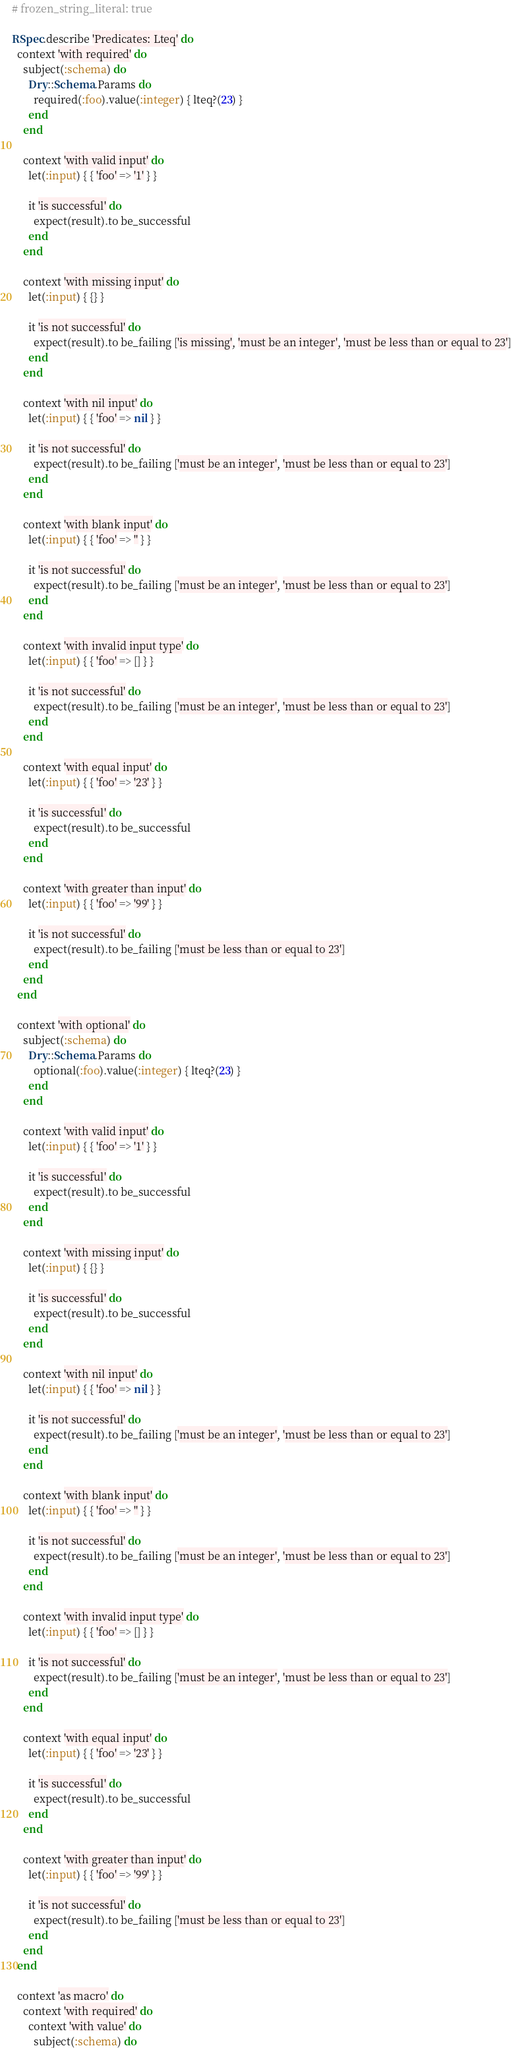Convert code to text. <code><loc_0><loc_0><loc_500><loc_500><_Ruby_># frozen_string_literal: true

RSpec.describe 'Predicates: Lteq' do
  context 'with required' do
    subject(:schema) do
      Dry::Schema.Params do
        required(:foo).value(:integer) { lteq?(23) }
      end
    end

    context 'with valid input' do
      let(:input) { { 'foo' => '1' } }

      it 'is successful' do
        expect(result).to be_successful
      end
    end

    context 'with missing input' do
      let(:input) { {} }

      it 'is not successful' do
        expect(result).to be_failing ['is missing', 'must be an integer', 'must be less than or equal to 23']
      end
    end

    context 'with nil input' do
      let(:input) { { 'foo' => nil } }

      it 'is not successful' do
        expect(result).to be_failing ['must be an integer', 'must be less than or equal to 23']
      end
    end

    context 'with blank input' do
      let(:input) { { 'foo' => '' } }

      it 'is not successful' do
        expect(result).to be_failing ['must be an integer', 'must be less than or equal to 23']
      end
    end

    context 'with invalid input type' do
      let(:input) { { 'foo' => [] } }

      it 'is not successful' do
        expect(result).to be_failing ['must be an integer', 'must be less than or equal to 23']
      end
    end

    context 'with equal input' do
      let(:input) { { 'foo' => '23' } }

      it 'is successful' do
        expect(result).to be_successful
      end
    end

    context 'with greater than input' do
      let(:input) { { 'foo' => '99' } }

      it 'is not successful' do
        expect(result).to be_failing ['must be less than or equal to 23']
      end
    end
  end

  context 'with optional' do
    subject(:schema) do
      Dry::Schema.Params do
        optional(:foo).value(:integer) { lteq?(23) }
      end
    end

    context 'with valid input' do
      let(:input) { { 'foo' => '1' } }

      it 'is successful' do
        expect(result).to be_successful
      end
    end

    context 'with missing input' do
      let(:input) { {} }

      it 'is successful' do
        expect(result).to be_successful
      end
    end

    context 'with nil input' do
      let(:input) { { 'foo' => nil } }

      it 'is not successful' do
        expect(result).to be_failing ['must be an integer', 'must be less than or equal to 23']
      end
    end

    context 'with blank input' do
      let(:input) { { 'foo' => '' } }

      it 'is not successful' do
        expect(result).to be_failing ['must be an integer', 'must be less than or equal to 23']
      end
    end

    context 'with invalid input type' do
      let(:input) { { 'foo' => [] } }

      it 'is not successful' do
        expect(result).to be_failing ['must be an integer', 'must be less than or equal to 23']
      end
    end

    context 'with equal input' do
      let(:input) { { 'foo' => '23' } }

      it 'is successful' do
        expect(result).to be_successful
      end
    end

    context 'with greater than input' do
      let(:input) { { 'foo' => '99' } }

      it 'is not successful' do
        expect(result).to be_failing ['must be less than or equal to 23']
      end
    end
  end

  context 'as macro' do
    context 'with required' do
      context 'with value' do
        subject(:schema) do</code> 